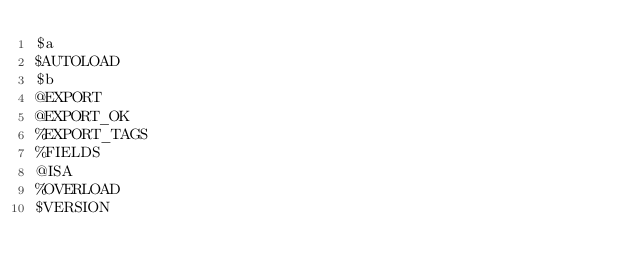Convert code to text. <code><loc_0><loc_0><loc_500><loc_500><_Perl_>$a
$AUTOLOAD
$b
@EXPORT
@EXPORT_OK
%EXPORT_TAGS
%FIELDS
@ISA
%OVERLOAD
$VERSION
</code> 